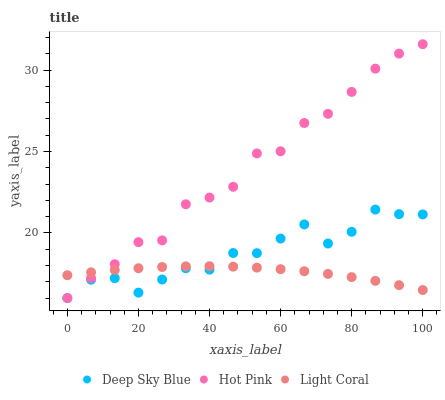Does Light Coral have the minimum area under the curve?
Answer yes or no. Yes. Does Hot Pink have the maximum area under the curve?
Answer yes or no. Yes. Does Deep Sky Blue have the minimum area under the curve?
Answer yes or no. No. Does Deep Sky Blue have the maximum area under the curve?
Answer yes or no. No. Is Light Coral the smoothest?
Answer yes or no. Yes. Is Deep Sky Blue the roughest?
Answer yes or no. Yes. Is Hot Pink the smoothest?
Answer yes or no. No. Is Hot Pink the roughest?
Answer yes or no. No. Does Hot Pink have the lowest value?
Answer yes or no. Yes. Does Hot Pink have the highest value?
Answer yes or no. Yes. Does Deep Sky Blue have the highest value?
Answer yes or no. No. Does Light Coral intersect Hot Pink?
Answer yes or no. Yes. Is Light Coral less than Hot Pink?
Answer yes or no. No. Is Light Coral greater than Hot Pink?
Answer yes or no. No. 